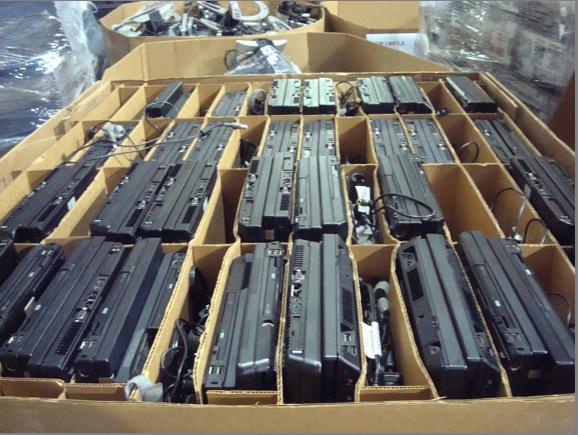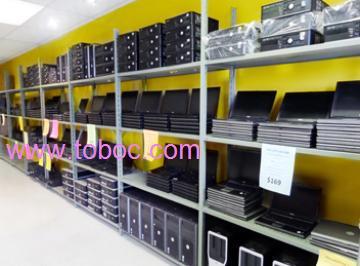The first image is the image on the left, the second image is the image on the right. Examine the images to the left and right. Is the description "In the image to the left, the electronics are in boxes." accurate? Answer yes or no. Yes. 